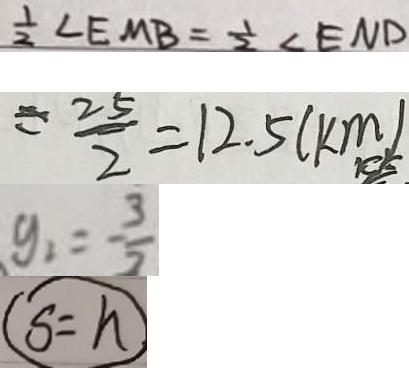<formula> <loc_0><loc_0><loc_500><loc_500>\frac { 1 } { 2 } \angle E M B = \frac { 1 } { 2 } \angle E N D 
 = \frac { 2 5 } { 2 } = 1 2 . 5 ( k m ) 
 y _ { 1 } = - \frac { 3 } { 2 } 
 s = h</formula> 